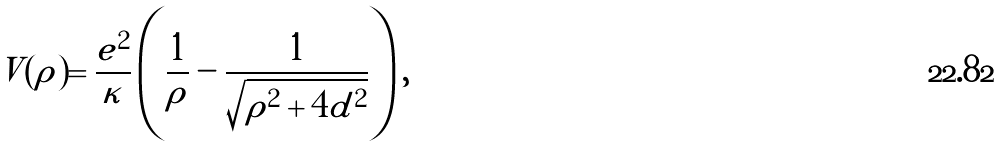<formula> <loc_0><loc_0><loc_500><loc_500>V ( \rho ) = \frac { e ^ { 2 } } { \kappa } \left ( \frac { 1 } { \rho } - \frac { 1 } { \sqrt { \rho ^ { 2 } + 4 d ^ { 2 } } } \right ) ,</formula> 